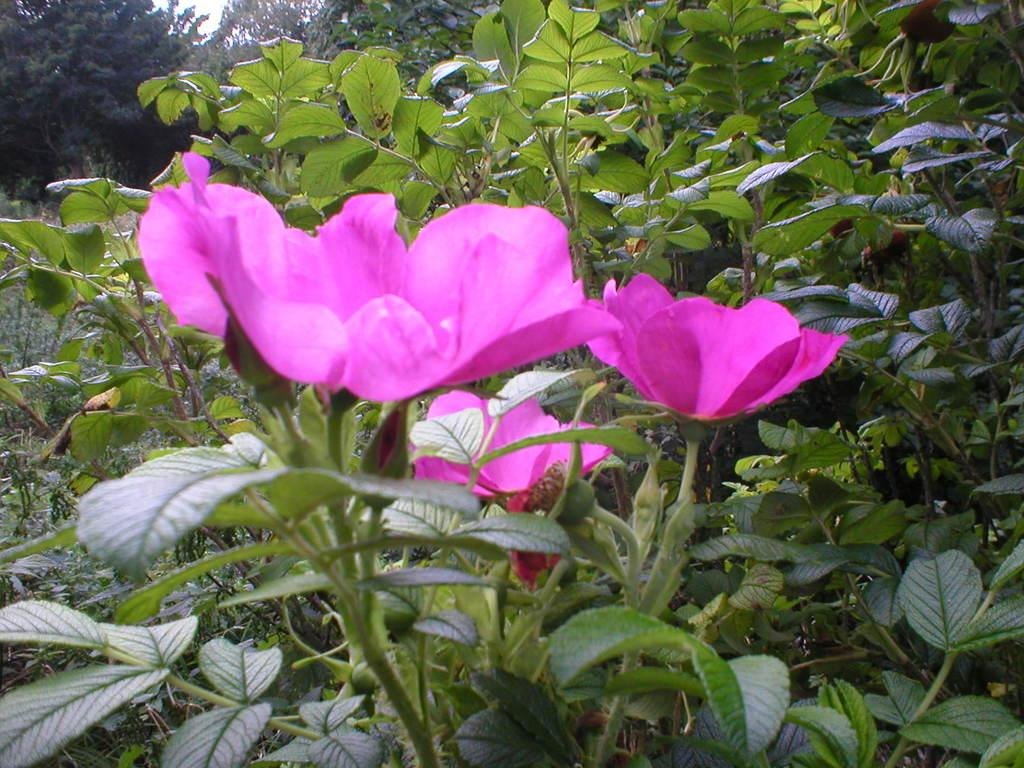What type of plant is visible in the image? There are flowers on a plant in the image. What other vegetation can be seen in the image? There are trees visible in the image. What type of crime is being committed in the image? There is no crime present in the image; it features flowers on a plant and trees. Can you hear the crow in the image? There is no crow present in the image, so it cannot be heard. 